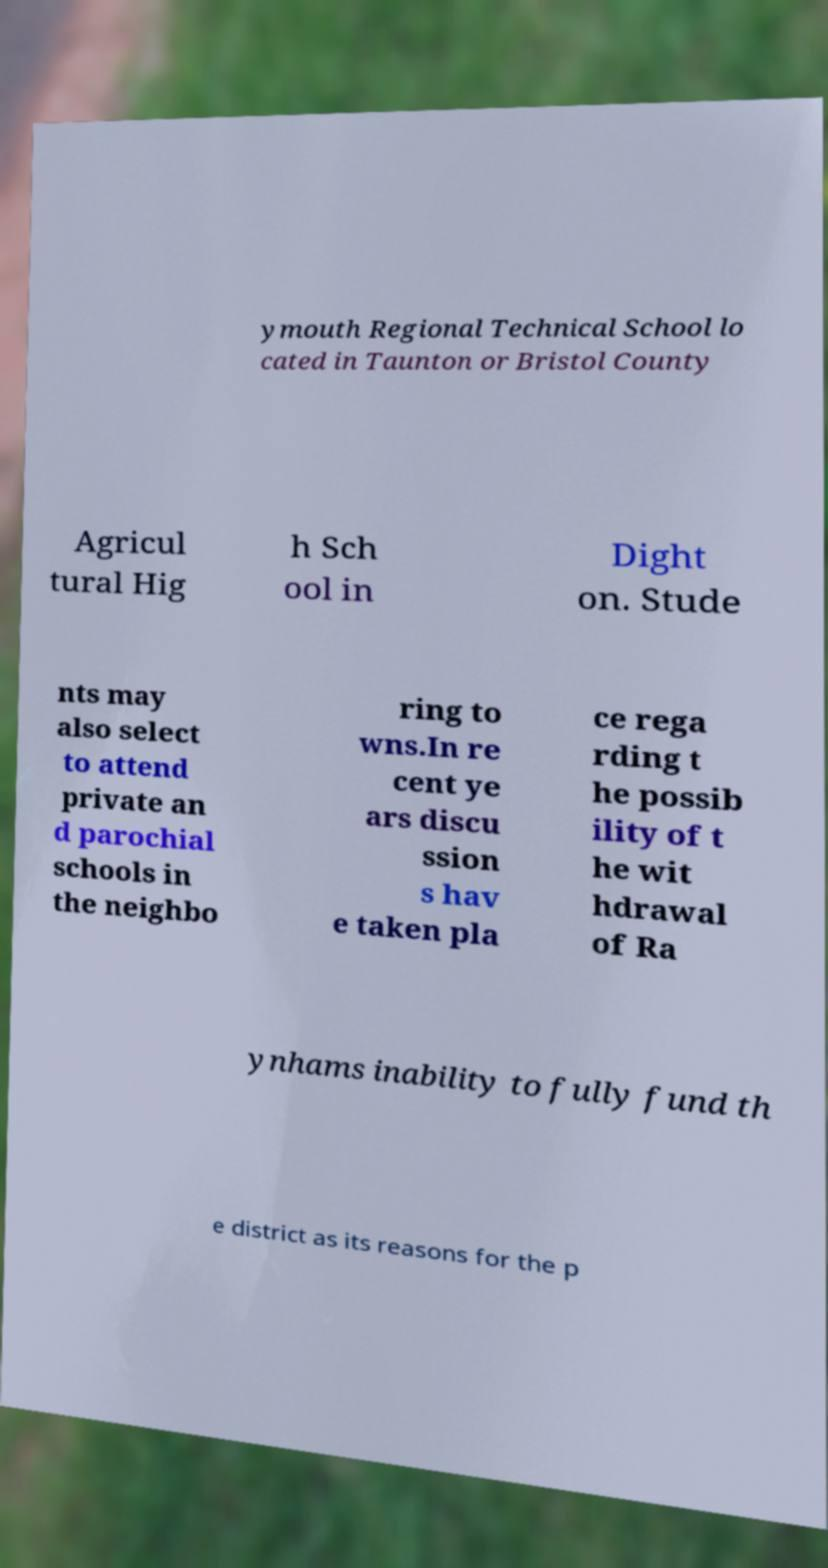There's text embedded in this image that I need extracted. Can you transcribe it verbatim? ymouth Regional Technical School lo cated in Taunton or Bristol County Agricul tural Hig h Sch ool in Dight on. Stude nts may also select to attend private an d parochial schools in the neighbo ring to wns.In re cent ye ars discu ssion s hav e taken pla ce rega rding t he possib ility of t he wit hdrawal of Ra ynhams inability to fully fund th e district as its reasons for the p 